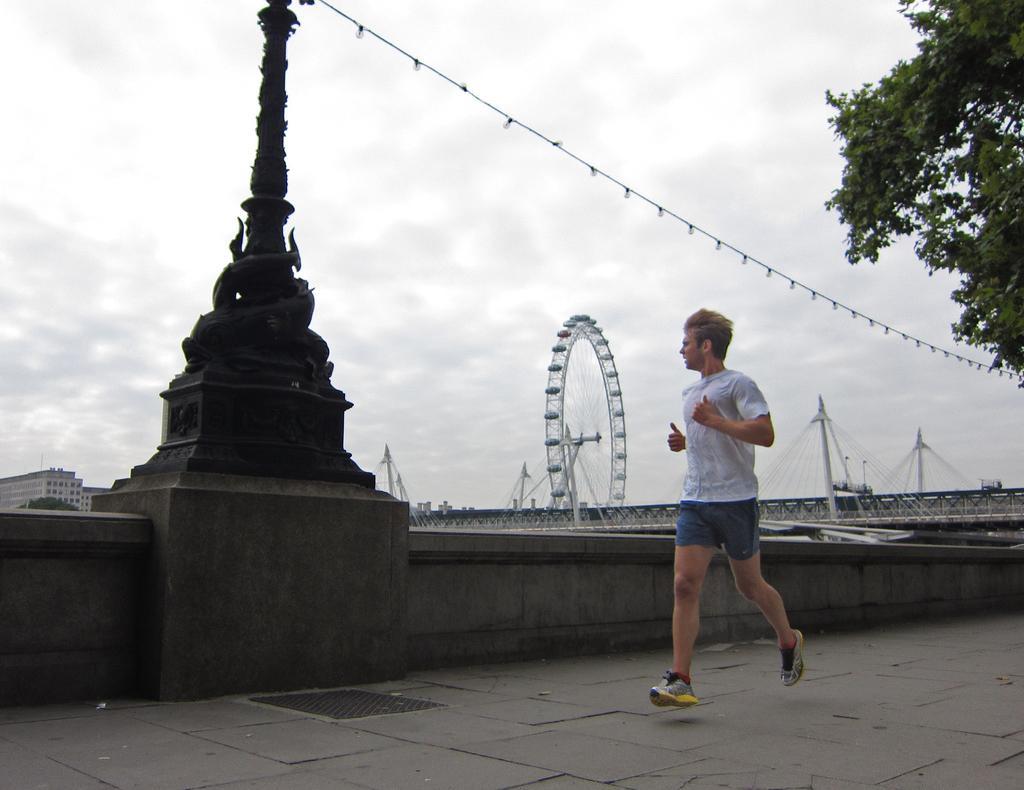Could you give a brief overview of what you see in this image? In the picture we can see a man jogging on the path, he is wearing a white T-shirt and beside him we can see a wall with a sculptured pole and behind it, we can see a bridge with the giant wheel and some poles with wires and behind the pole we can see a building with windows and in the background we can see a sky with clouds. 